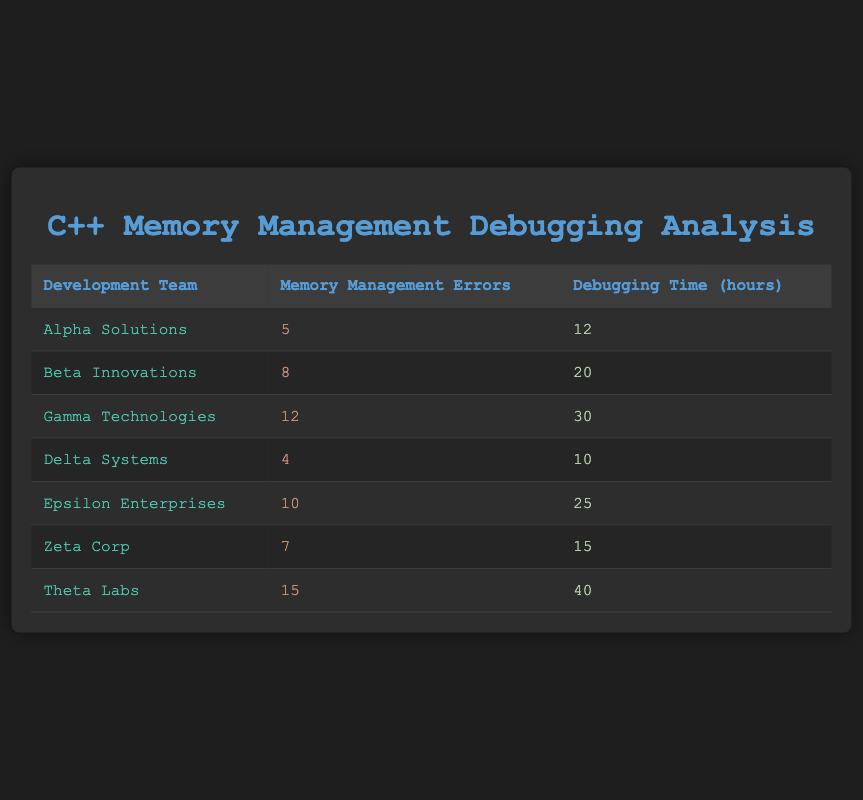What is the total number of memory management errors reported by all teams? To find the total number of memory management errors reported by all teams, we sum the errors in each row: 5 (Alpha) + 8 (Beta) + 12 (Gamma) + 4 (Delta) + 10 (Epsilon) + 7 (Zeta) + 15 (Theta) = 61
Answer: 61 Which team has the highest debugging time? By looking at the debugging time column, Theta Labs has 40 hours, which is the highest value among all teams.
Answer: Theta Labs Is it true that Epsilon Enterprises reported more memory management errors than Alpha Solutions? Epsilon Enterprises has 10 errors, while Alpha Solutions has 5 errors. Since 10 is greater than 5, the statement is true.
Answer: Yes Calculate the average debugging time across all teams. We have 7 teams with the following debugging times: 12, 20, 30, 10, 25, 15, and 40 hours. The sum is 12 + 20 + 30 + 10 + 25 + 15 + 40 = 152 hours. Dividing by the number of teams (7) gives an average of 152 / 7 ≈ 21.71 hours.
Answer: 21.7 hours Which team has the lowest ratio of debugging time to memory management errors? We calculate the ratio for each team: Alpha (12/5 = 2.4), Beta (20/8 = 2.5), Gamma (30/12 = 2.5), Delta (10/4 = 2.5), Epsilon (25/10 = 2.5), Zeta (15/7 ≈ 2.14), Theta (40/15 ≈ 2.67). Zeta Corp has the lowest ratio of approximately 2.14.
Answer: Zeta Corp Did any team report the same number of memory management errors? Checking the memory management errors, no teams have the same value; each team listed has a unique count of errors. Therefore, the answer is no.
Answer: No What is the difference in debugging time between the team with the most errors and the team with the least? Theta Labs has the most errors (15) and has a debugging time of 40 hours, while Delta Systems has the least errors (4) and a debugging time of 10 hours. The difference is 40 - 10 = 30 hours.
Answer: 30 hours 